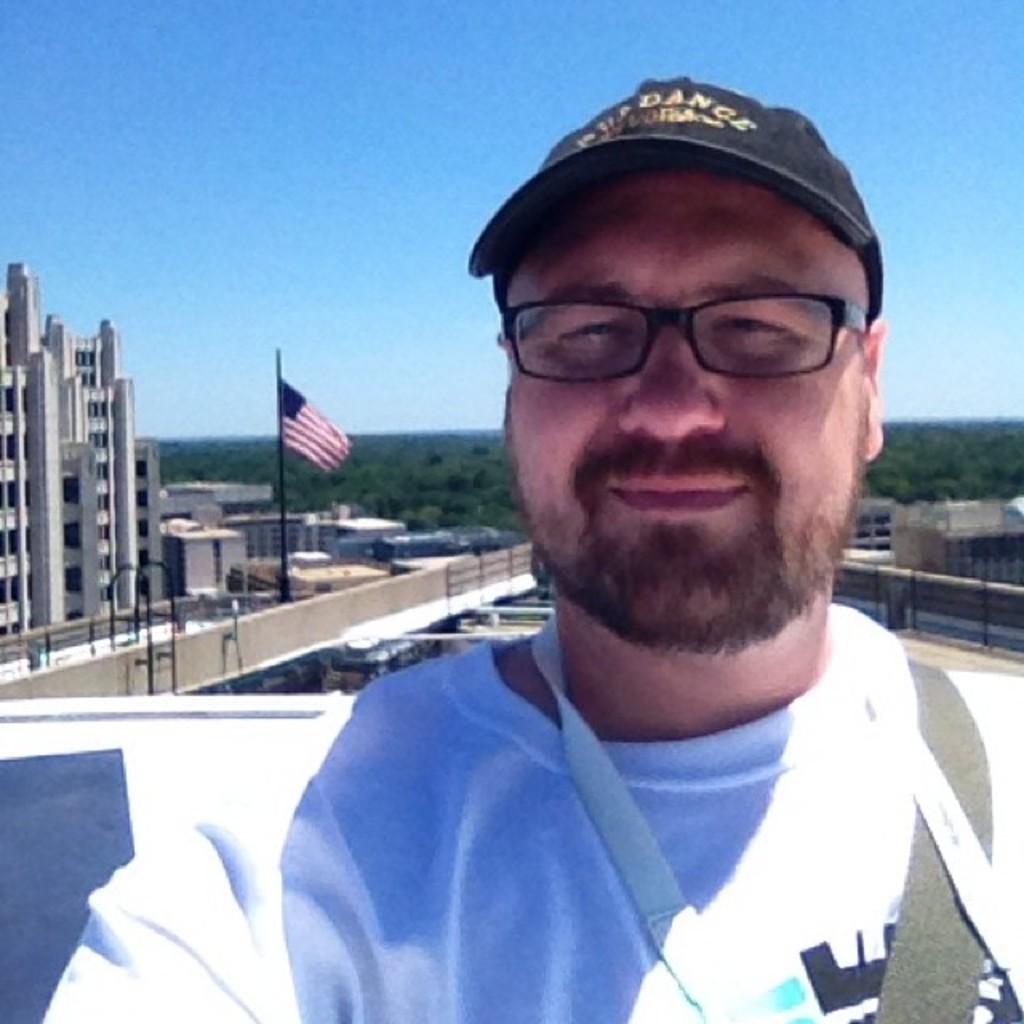Please provide a concise description of this image. In this picture we can see a person, he is wearing a cap, spectacles, at the back of him we can see a flag, buildings, trees and some objects and we can see sky in the background. 